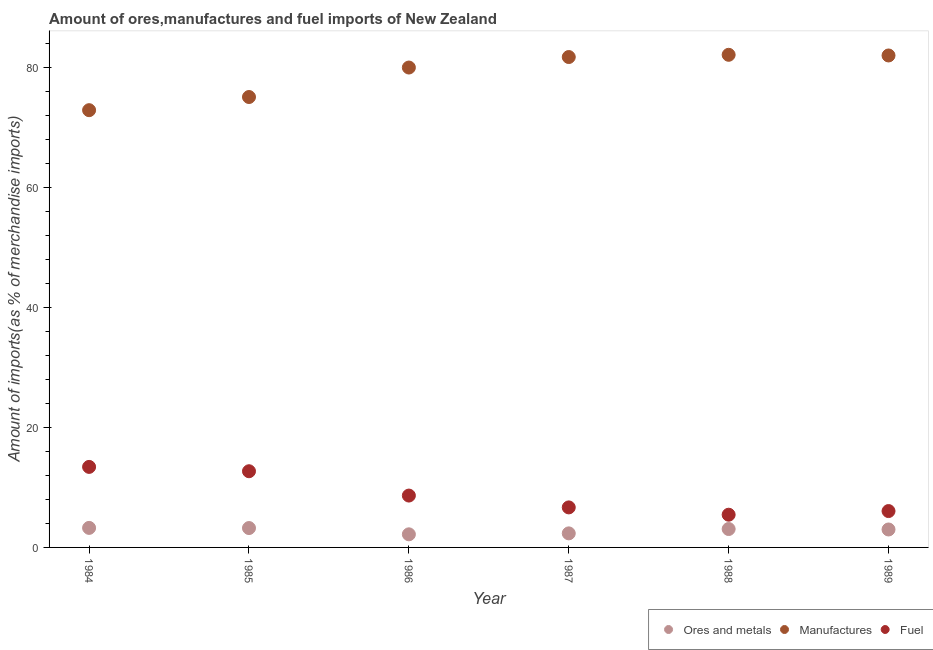Is the number of dotlines equal to the number of legend labels?
Offer a terse response. Yes. What is the percentage of ores and metals imports in 1987?
Ensure brevity in your answer.  2.34. Across all years, what is the maximum percentage of ores and metals imports?
Offer a terse response. 3.26. Across all years, what is the minimum percentage of manufactures imports?
Offer a terse response. 72.89. What is the total percentage of manufactures imports in the graph?
Offer a very short reply. 473.87. What is the difference between the percentage of manufactures imports in 1985 and that in 1986?
Offer a very short reply. -4.91. What is the difference between the percentage of fuel imports in 1989 and the percentage of ores and metals imports in 1987?
Provide a short and direct response. 3.72. What is the average percentage of manufactures imports per year?
Ensure brevity in your answer.  78.98. In the year 1985, what is the difference between the percentage of fuel imports and percentage of manufactures imports?
Provide a succinct answer. -62.39. What is the ratio of the percentage of fuel imports in 1985 to that in 1989?
Give a very brief answer. 2.1. Is the difference between the percentage of fuel imports in 1984 and 1989 greater than the difference between the percentage of manufactures imports in 1984 and 1989?
Your response must be concise. Yes. What is the difference between the highest and the second highest percentage of ores and metals imports?
Your answer should be compact. 0.03. What is the difference between the highest and the lowest percentage of fuel imports?
Make the answer very short. 7.97. In how many years, is the percentage of fuel imports greater than the average percentage of fuel imports taken over all years?
Your response must be concise. 2. Is the sum of the percentage of ores and metals imports in 1988 and 1989 greater than the maximum percentage of manufactures imports across all years?
Make the answer very short. No. Does the percentage of ores and metals imports monotonically increase over the years?
Give a very brief answer. No. Is the percentage of manufactures imports strictly greater than the percentage of ores and metals imports over the years?
Your answer should be very brief. Yes. How many dotlines are there?
Give a very brief answer. 3. Are the values on the major ticks of Y-axis written in scientific E-notation?
Your response must be concise. No. Does the graph contain any zero values?
Provide a succinct answer. No. Where does the legend appear in the graph?
Offer a very short reply. Bottom right. How many legend labels are there?
Your response must be concise. 3. What is the title of the graph?
Your answer should be compact. Amount of ores,manufactures and fuel imports of New Zealand. Does "Solid fuel" appear as one of the legend labels in the graph?
Your response must be concise. No. What is the label or title of the Y-axis?
Keep it short and to the point. Amount of imports(as % of merchandise imports). What is the Amount of imports(as % of merchandise imports) in Ores and metals in 1984?
Give a very brief answer. 3.26. What is the Amount of imports(as % of merchandise imports) of Manufactures in 1984?
Your response must be concise. 72.89. What is the Amount of imports(as % of merchandise imports) in Fuel in 1984?
Your answer should be compact. 13.42. What is the Amount of imports(as % of merchandise imports) in Ores and metals in 1985?
Your response must be concise. 3.23. What is the Amount of imports(as % of merchandise imports) of Manufactures in 1985?
Your response must be concise. 75.09. What is the Amount of imports(as % of merchandise imports) in Fuel in 1985?
Your answer should be very brief. 12.7. What is the Amount of imports(as % of merchandise imports) of Ores and metals in 1986?
Ensure brevity in your answer.  2.18. What is the Amount of imports(as % of merchandise imports) of Manufactures in 1986?
Make the answer very short. 80. What is the Amount of imports(as % of merchandise imports) of Fuel in 1986?
Keep it short and to the point. 8.64. What is the Amount of imports(as % of merchandise imports) in Ores and metals in 1987?
Provide a short and direct response. 2.34. What is the Amount of imports(as % of merchandise imports) in Manufactures in 1987?
Ensure brevity in your answer.  81.75. What is the Amount of imports(as % of merchandise imports) of Fuel in 1987?
Your answer should be very brief. 6.67. What is the Amount of imports(as % of merchandise imports) in Ores and metals in 1988?
Ensure brevity in your answer.  3.07. What is the Amount of imports(as % of merchandise imports) of Manufactures in 1988?
Provide a succinct answer. 82.12. What is the Amount of imports(as % of merchandise imports) in Fuel in 1988?
Your answer should be very brief. 5.45. What is the Amount of imports(as % of merchandise imports) of Ores and metals in 1989?
Your answer should be very brief. 2.99. What is the Amount of imports(as % of merchandise imports) in Manufactures in 1989?
Keep it short and to the point. 82.01. What is the Amount of imports(as % of merchandise imports) of Fuel in 1989?
Your response must be concise. 6.06. Across all years, what is the maximum Amount of imports(as % of merchandise imports) of Ores and metals?
Provide a short and direct response. 3.26. Across all years, what is the maximum Amount of imports(as % of merchandise imports) in Manufactures?
Make the answer very short. 82.12. Across all years, what is the maximum Amount of imports(as % of merchandise imports) of Fuel?
Your response must be concise. 13.42. Across all years, what is the minimum Amount of imports(as % of merchandise imports) of Ores and metals?
Your answer should be compact. 2.18. Across all years, what is the minimum Amount of imports(as % of merchandise imports) in Manufactures?
Make the answer very short. 72.89. Across all years, what is the minimum Amount of imports(as % of merchandise imports) in Fuel?
Ensure brevity in your answer.  5.45. What is the total Amount of imports(as % of merchandise imports) in Ores and metals in the graph?
Make the answer very short. 17.08. What is the total Amount of imports(as % of merchandise imports) of Manufactures in the graph?
Ensure brevity in your answer.  473.87. What is the total Amount of imports(as % of merchandise imports) of Fuel in the graph?
Offer a terse response. 52.96. What is the difference between the Amount of imports(as % of merchandise imports) in Ores and metals in 1984 and that in 1985?
Your response must be concise. 0.03. What is the difference between the Amount of imports(as % of merchandise imports) in Manufactures in 1984 and that in 1985?
Your answer should be compact. -2.19. What is the difference between the Amount of imports(as % of merchandise imports) of Fuel in 1984 and that in 1985?
Offer a very short reply. 0.72. What is the difference between the Amount of imports(as % of merchandise imports) of Ores and metals in 1984 and that in 1986?
Your answer should be compact. 1.07. What is the difference between the Amount of imports(as % of merchandise imports) in Manufactures in 1984 and that in 1986?
Your answer should be very brief. -7.11. What is the difference between the Amount of imports(as % of merchandise imports) of Fuel in 1984 and that in 1986?
Give a very brief answer. 4.78. What is the difference between the Amount of imports(as % of merchandise imports) of Ores and metals in 1984 and that in 1987?
Your answer should be very brief. 0.91. What is the difference between the Amount of imports(as % of merchandise imports) in Manufactures in 1984 and that in 1987?
Ensure brevity in your answer.  -8.86. What is the difference between the Amount of imports(as % of merchandise imports) in Fuel in 1984 and that in 1987?
Keep it short and to the point. 6.75. What is the difference between the Amount of imports(as % of merchandise imports) of Ores and metals in 1984 and that in 1988?
Your answer should be compact. 0.19. What is the difference between the Amount of imports(as % of merchandise imports) of Manufactures in 1984 and that in 1988?
Your answer should be compact. -9.23. What is the difference between the Amount of imports(as % of merchandise imports) in Fuel in 1984 and that in 1988?
Ensure brevity in your answer.  7.97. What is the difference between the Amount of imports(as % of merchandise imports) of Ores and metals in 1984 and that in 1989?
Keep it short and to the point. 0.26. What is the difference between the Amount of imports(as % of merchandise imports) in Manufactures in 1984 and that in 1989?
Make the answer very short. -9.12. What is the difference between the Amount of imports(as % of merchandise imports) of Fuel in 1984 and that in 1989?
Your answer should be compact. 7.36. What is the difference between the Amount of imports(as % of merchandise imports) in Ores and metals in 1985 and that in 1986?
Your response must be concise. 1.05. What is the difference between the Amount of imports(as % of merchandise imports) in Manufactures in 1985 and that in 1986?
Your response must be concise. -4.91. What is the difference between the Amount of imports(as % of merchandise imports) of Fuel in 1985 and that in 1986?
Offer a terse response. 4.06. What is the difference between the Amount of imports(as % of merchandise imports) in Ores and metals in 1985 and that in 1987?
Ensure brevity in your answer.  0.89. What is the difference between the Amount of imports(as % of merchandise imports) in Manufactures in 1985 and that in 1987?
Provide a succinct answer. -6.66. What is the difference between the Amount of imports(as % of merchandise imports) of Fuel in 1985 and that in 1987?
Offer a very short reply. 6.03. What is the difference between the Amount of imports(as % of merchandise imports) in Ores and metals in 1985 and that in 1988?
Provide a succinct answer. 0.16. What is the difference between the Amount of imports(as % of merchandise imports) in Manufactures in 1985 and that in 1988?
Provide a short and direct response. -7.04. What is the difference between the Amount of imports(as % of merchandise imports) of Fuel in 1985 and that in 1988?
Keep it short and to the point. 7.25. What is the difference between the Amount of imports(as % of merchandise imports) of Ores and metals in 1985 and that in 1989?
Your answer should be compact. 0.24. What is the difference between the Amount of imports(as % of merchandise imports) in Manufactures in 1985 and that in 1989?
Your answer should be very brief. -6.92. What is the difference between the Amount of imports(as % of merchandise imports) in Fuel in 1985 and that in 1989?
Your answer should be compact. 6.64. What is the difference between the Amount of imports(as % of merchandise imports) of Ores and metals in 1986 and that in 1987?
Ensure brevity in your answer.  -0.16. What is the difference between the Amount of imports(as % of merchandise imports) in Manufactures in 1986 and that in 1987?
Provide a succinct answer. -1.75. What is the difference between the Amount of imports(as % of merchandise imports) of Fuel in 1986 and that in 1987?
Ensure brevity in your answer.  1.97. What is the difference between the Amount of imports(as % of merchandise imports) of Ores and metals in 1986 and that in 1988?
Keep it short and to the point. -0.88. What is the difference between the Amount of imports(as % of merchandise imports) in Manufactures in 1986 and that in 1988?
Give a very brief answer. -2.12. What is the difference between the Amount of imports(as % of merchandise imports) in Fuel in 1986 and that in 1988?
Your answer should be compact. 3.19. What is the difference between the Amount of imports(as % of merchandise imports) in Ores and metals in 1986 and that in 1989?
Your answer should be compact. -0.81. What is the difference between the Amount of imports(as % of merchandise imports) in Manufactures in 1986 and that in 1989?
Your response must be concise. -2.01. What is the difference between the Amount of imports(as % of merchandise imports) of Fuel in 1986 and that in 1989?
Your answer should be compact. 2.58. What is the difference between the Amount of imports(as % of merchandise imports) in Ores and metals in 1987 and that in 1988?
Your response must be concise. -0.73. What is the difference between the Amount of imports(as % of merchandise imports) in Manufactures in 1987 and that in 1988?
Your response must be concise. -0.37. What is the difference between the Amount of imports(as % of merchandise imports) of Fuel in 1987 and that in 1988?
Your answer should be very brief. 1.22. What is the difference between the Amount of imports(as % of merchandise imports) of Ores and metals in 1987 and that in 1989?
Your answer should be compact. -0.65. What is the difference between the Amount of imports(as % of merchandise imports) of Manufactures in 1987 and that in 1989?
Provide a succinct answer. -0.26. What is the difference between the Amount of imports(as % of merchandise imports) of Fuel in 1987 and that in 1989?
Your response must be concise. 0.61. What is the difference between the Amount of imports(as % of merchandise imports) of Ores and metals in 1988 and that in 1989?
Offer a very short reply. 0.08. What is the difference between the Amount of imports(as % of merchandise imports) of Manufactures in 1988 and that in 1989?
Your answer should be compact. 0.11. What is the difference between the Amount of imports(as % of merchandise imports) of Fuel in 1988 and that in 1989?
Provide a succinct answer. -0.61. What is the difference between the Amount of imports(as % of merchandise imports) of Ores and metals in 1984 and the Amount of imports(as % of merchandise imports) of Manufactures in 1985?
Give a very brief answer. -71.83. What is the difference between the Amount of imports(as % of merchandise imports) of Ores and metals in 1984 and the Amount of imports(as % of merchandise imports) of Fuel in 1985?
Your response must be concise. -9.45. What is the difference between the Amount of imports(as % of merchandise imports) of Manufactures in 1984 and the Amount of imports(as % of merchandise imports) of Fuel in 1985?
Ensure brevity in your answer.  60.19. What is the difference between the Amount of imports(as % of merchandise imports) in Ores and metals in 1984 and the Amount of imports(as % of merchandise imports) in Manufactures in 1986?
Provide a succinct answer. -76.75. What is the difference between the Amount of imports(as % of merchandise imports) in Ores and metals in 1984 and the Amount of imports(as % of merchandise imports) in Fuel in 1986?
Provide a succinct answer. -5.39. What is the difference between the Amount of imports(as % of merchandise imports) of Manufactures in 1984 and the Amount of imports(as % of merchandise imports) of Fuel in 1986?
Give a very brief answer. 64.25. What is the difference between the Amount of imports(as % of merchandise imports) in Ores and metals in 1984 and the Amount of imports(as % of merchandise imports) in Manufactures in 1987?
Offer a very short reply. -78.5. What is the difference between the Amount of imports(as % of merchandise imports) in Ores and metals in 1984 and the Amount of imports(as % of merchandise imports) in Fuel in 1987?
Keep it short and to the point. -3.42. What is the difference between the Amount of imports(as % of merchandise imports) in Manufactures in 1984 and the Amount of imports(as % of merchandise imports) in Fuel in 1987?
Your answer should be very brief. 66.22. What is the difference between the Amount of imports(as % of merchandise imports) in Ores and metals in 1984 and the Amount of imports(as % of merchandise imports) in Manufactures in 1988?
Offer a terse response. -78.87. What is the difference between the Amount of imports(as % of merchandise imports) in Ores and metals in 1984 and the Amount of imports(as % of merchandise imports) in Fuel in 1988?
Your response must be concise. -2.2. What is the difference between the Amount of imports(as % of merchandise imports) of Manufactures in 1984 and the Amount of imports(as % of merchandise imports) of Fuel in 1988?
Your answer should be very brief. 67.44. What is the difference between the Amount of imports(as % of merchandise imports) of Ores and metals in 1984 and the Amount of imports(as % of merchandise imports) of Manufactures in 1989?
Your answer should be compact. -78.76. What is the difference between the Amount of imports(as % of merchandise imports) of Ores and metals in 1984 and the Amount of imports(as % of merchandise imports) of Fuel in 1989?
Provide a short and direct response. -2.81. What is the difference between the Amount of imports(as % of merchandise imports) of Manufactures in 1984 and the Amount of imports(as % of merchandise imports) of Fuel in 1989?
Provide a succinct answer. 66.83. What is the difference between the Amount of imports(as % of merchandise imports) in Ores and metals in 1985 and the Amount of imports(as % of merchandise imports) in Manufactures in 1986?
Give a very brief answer. -76.77. What is the difference between the Amount of imports(as % of merchandise imports) in Ores and metals in 1985 and the Amount of imports(as % of merchandise imports) in Fuel in 1986?
Give a very brief answer. -5.41. What is the difference between the Amount of imports(as % of merchandise imports) of Manufactures in 1985 and the Amount of imports(as % of merchandise imports) of Fuel in 1986?
Ensure brevity in your answer.  66.44. What is the difference between the Amount of imports(as % of merchandise imports) in Ores and metals in 1985 and the Amount of imports(as % of merchandise imports) in Manufactures in 1987?
Provide a short and direct response. -78.52. What is the difference between the Amount of imports(as % of merchandise imports) in Ores and metals in 1985 and the Amount of imports(as % of merchandise imports) in Fuel in 1987?
Provide a succinct answer. -3.44. What is the difference between the Amount of imports(as % of merchandise imports) in Manufactures in 1985 and the Amount of imports(as % of merchandise imports) in Fuel in 1987?
Offer a terse response. 68.42. What is the difference between the Amount of imports(as % of merchandise imports) in Ores and metals in 1985 and the Amount of imports(as % of merchandise imports) in Manufactures in 1988?
Offer a terse response. -78.89. What is the difference between the Amount of imports(as % of merchandise imports) in Ores and metals in 1985 and the Amount of imports(as % of merchandise imports) in Fuel in 1988?
Ensure brevity in your answer.  -2.22. What is the difference between the Amount of imports(as % of merchandise imports) of Manufactures in 1985 and the Amount of imports(as % of merchandise imports) of Fuel in 1988?
Your answer should be very brief. 69.63. What is the difference between the Amount of imports(as % of merchandise imports) of Ores and metals in 1985 and the Amount of imports(as % of merchandise imports) of Manufactures in 1989?
Keep it short and to the point. -78.78. What is the difference between the Amount of imports(as % of merchandise imports) of Ores and metals in 1985 and the Amount of imports(as % of merchandise imports) of Fuel in 1989?
Offer a very short reply. -2.83. What is the difference between the Amount of imports(as % of merchandise imports) of Manufactures in 1985 and the Amount of imports(as % of merchandise imports) of Fuel in 1989?
Offer a terse response. 69.03. What is the difference between the Amount of imports(as % of merchandise imports) in Ores and metals in 1986 and the Amount of imports(as % of merchandise imports) in Manufactures in 1987?
Keep it short and to the point. -79.57. What is the difference between the Amount of imports(as % of merchandise imports) of Ores and metals in 1986 and the Amount of imports(as % of merchandise imports) of Fuel in 1987?
Your answer should be compact. -4.49. What is the difference between the Amount of imports(as % of merchandise imports) in Manufactures in 1986 and the Amount of imports(as % of merchandise imports) in Fuel in 1987?
Keep it short and to the point. 73.33. What is the difference between the Amount of imports(as % of merchandise imports) of Ores and metals in 1986 and the Amount of imports(as % of merchandise imports) of Manufactures in 1988?
Your response must be concise. -79.94. What is the difference between the Amount of imports(as % of merchandise imports) in Ores and metals in 1986 and the Amount of imports(as % of merchandise imports) in Fuel in 1988?
Make the answer very short. -3.27. What is the difference between the Amount of imports(as % of merchandise imports) in Manufactures in 1986 and the Amount of imports(as % of merchandise imports) in Fuel in 1988?
Your answer should be compact. 74.55. What is the difference between the Amount of imports(as % of merchandise imports) in Ores and metals in 1986 and the Amount of imports(as % of merchandise imports) in Manufactures in 1989?
Your response must be concise. -79.83. What is the difference between the Amount of imports(as % of merchandise imports) of Ores and metals in 1986 and the Amount of imports(as % of merchandise imports) of Fuel in 1989?
Provide a succinct answer. -3.88. What is the difference between the Amount of imports(as % of merchandise imports) of Manufactures in 1986 and the Amount of imports(as % of merchandise imports) of Fuel in 1989?
Your response must be concise. 73.94. What is the difference between the Amount of imports(as % of merchandise imports) in Ores and metals in 1987 and the Amount of imports(as % of merchandise imports) in Manufactures in 1988?
Offer a terse response. -79.78. What is the difference between the Amount of imports(as % of merchandise imports) in Ores and metals in 1987 and the Amount of imports(as % of merchandise imports) in Fuel in 1988?
Provide a succinct answer. -3.11. What is the difference between the Amount of imports(as % of merchandise imports) of Manufactures in 1987 and the Amount of imports(as % of merchandise imports) of Fuel in 1988?
Make the answer very short. 76.3. What is the difference between the Amount of imports(as % of merchandise imports) in Ores and metals in 1987 and the Amount of imports(as % of merchandise imports) in Manufactures in 1989?
Keep it short and to the point. -79.67. What is the difference between the Amount of imports(as % of merchandise imports) of Ores and metals in 1987 and the Amount of imports(as % of merchandise imports) of Fuel in 1989?
Provide a short and direct response. -3.72. What is the difference between the Amount of imports(as % of merchandise imports) of Manufactures in 1987 and the Amount of imports(as % of merchandise imports) of Fuel in 1989?
Give a very brief answer. 75.69. What is the difference between the Amount of imports(as % of merchandise imports) of Ores and metals in 1988 and the Amount of imports(as % of merchandise imports) of Manufactures in 1989?
Make the answer very short. -78.94. What is the difference between the Amount of imports(as % of merchandise imports) in Ores and metals in 1988 and the Amount of imports(as % of merchandise imports) in Fuel in 1989?
Keep it short and to the point. -2.99. What is the difference between the Amount of imports(as % of merchandise imports) of Manufactures in 1988 and the Amount of imports(as % of merchandise imports) of Fuel in 1989?
Your answer should be compact. 76.06. What is the average Amount of imports(as % of merchandise imports) in Ores and metals per year?
Your response must be concise. 2.85. What is the average Amount of imports(as % of merchandise imports) of Manufactures per year?
Offer a very short reply. 78.98. What is the average Amount of imports(as % of merchandise imports) in Fuel per year?
Offer a terse response. 8.83. In the year 1984, what is the difference between the Amount of imports(as % of merchandise imports) in Ores and metals and Amount of imports(as % of merchandise imports) in Manufactures?
Keep it short and to the point. -69.64. In the year 1984, what is the difference between the Amount of imports(as % of merchandise imports) of Ores and metals and Amount of imports(as % of merchandise imports) of Fuel?
Your answer should be compact. -10.17. In the year 1984, what is the difference between the Amount of imports(as % of merchandise imports) of Manufactures and Amount of imports(as % of merchandise imports) of Fuel?
Keep it short and to the point. 59.47. In the year 1985, what is the difference between the Amount of imports(as % of merchandise imports) in Ores and metals and Amount of imports(as % of merchandise imports) in Manufactures?
Give a very brief answer. -71.86. In the year 1985, what is the difference between the Amount of imports(as % of merchandise imports) of Ores and metals and Amount of imports(as % of merchandise imports) of Fuel?
Ensure brevity in your answer.  -9.47. In the year 1985, what is the difference between the Amount of imports(as % of merchandise imports) of Manufactures and Amount of imports(as % of merchandise imports) of Fuel?
Offer a terse response. 62.39. In the year 1986, what is the difference between the Amount of imports(as % of merchandise imports) in Ores and metals and Amount of imports(as % of merchandise imports) in Manufactures?
Your response must be concise. -77.82. In the year 1986, what is the difference between the Amount of imports(as % of merchandise imports) in Ores and metals and Amount of imports(as % of merchandise imports) in Fuel?
Offer a very short reply. -6.46. In the year 1986, what is the difference between the Amount of imports(as % of merchandise imports) in Manufactures and Amount of imports(as % of merchandise imports) in Fuel?
Offer a terse response. 71.36. In the year 1987, what is the difference between the Amount of imports(as % of merchandise imports) of Ores and metals and Amount of imports(as % of merchandise imports) of Manufactures?
Give a very brief answer. -79.41. In the year 1987, what is the difference between the Amount of imports(as % of merchandise imports) of Ores and metals and Amount of imports(as % of merchandise imports) of Fuel?
Offer a terse response. -4.33. In the year 1987, what is the difference between the Amount of imports(as % of merchandise imports) in Manufactures and Amount of imports(as % of merchandise imports) in Fuel?
Give a very brief answer. 75.08. In the year 1988, what is the difference between the Amount of imports(as % of merchandise imports) of Ores and metals and Amount of imports(as % of merchandise imports) of Manufactures?
Offer a terse response. -79.05. In the year 1988, what is the difference between the Amount of imports(as % of merchandise imports) in Ores and metals and Amount of imports(as % of merchandise imports) in Fuel?
Your response must be concise. -2.39. In the year 1988, what is the difference between the Amount of imports(as % of merchandise imports) in Manufactures and Amount of imports(as % of merchandise imports) in Fuel?
Provide a short and direct response. 76.67. In the year 1989, what is the difference between the Amount of imports(as % of merchandise imports) of Ores and metals and Amount of imports(as % of merchandise imports) of Manufactures?
Your answer should be very brief. -79.02. In the year 1989, what is the difference between the Amount of imports(as % of merchandise imports) of Ores and metals and Amount of imports(as % of merchandise imports) of Fuel?
Offer a terse response. -3.07. In the year 1989, what is the difference between the Amount of imports(as % of merchandise imports) of Manufactures and Amount of imports(as % of merchandise imports) of Fuel?
Your response must be concise. 75.95. What is the ratio of the Amount of imports(as % of merchandise imports) in Manufactures in 1984 to that in 1985?
Your answer should be compact. 0.97. What is the ratio of the Amount of imports(as % of merchandise imports) of Fuel in 1984 to that in 1985?
Provide a short and direct response. 1.06. What is the ratio of the Amount of imports(as % of merchandise imports) in Ores and metals in 1984 to that in 1986?
Make the answer very short. 1.49. What is the ratio of the Amount of imports(as % of merchandise imports) in Manufactures in 1984 to that in 1986?
Keep it short and to the point. 0.91. What is the ratio of the Amount of imports(as % of merchandise imports) of Fuel in 1984 to that in 1986?
Your answer should be very brief. 1.55. What is the ratio of the Amount of imports(as % of merchandise imports) of Ores and metals in 1984 to that in 1987?
Your response must be concise. 1.39. What is the ratio of the Amount of imports(as % of merchandise imports) of Manufactures in 1984 to that in 1987?
Provide a succinct answer. 0.89. What is the ratio of the Amount of imports(as % of merchandise imports) of Fuel in 1984 to that in 1987?
Give a very brief answer. 2.01. What is the ratio of the Amount of imports(as % of merchandise imports) in Ores and metals in 1984 to that in 1988?
Your answer should be very brief. 1.06. What is the ratio of the Amount of imports(as % of merchandise imports) in Manufactures in 1984 to that in 1988?
Keep it short and to the point. 0.89. What is the ratio of the Amount of imports(as % of merchandise imports) of Fuel in 1984 to that in 1988?
Provide a succinct answer. 2.46. What is the ratio of the Amount of imports(as % of merchandise imports) in Ores and metals in 1984 to that in 1989?
Give a very brief answer. 1.09. What is the ratio of the Amount of imports(as % of merchandise imports) in Manufactures in 1984 to that in 1989?
Offer a very short reply. 0.89. What is the ratio of the Amount of imports(as % of merchandise imports) of Fuel in 1984 to that in 1989?
Your response must be concise. 2.21. What is the ratio of the Amount of imports(as % of merchandise imports) in Ores and metals in 1985 to that in 1986?
Offer a very short reply. 1.48. What is the ratio of the Amount of imports(as % of merchandise imports) of Manufactures in 1985 to that in 1986?
Make the answer very short. 0.94. What is the ratio of the Amount of imports(as % of merchandise imports) in Fuel in 1985 to that in 1986?
Keep it short and to the point. 1.47. What is the ratio of the Amount of imports(as % of merchandise imports) of Ores and metals in 1985 to that in 1987?
Keep it short and to the point. 1.38. What is the ratio of the Amount of imports(as % of merchandise imports) of Manufactures in 1985 to that in 1987?
Your response must be concise. 0.92. What is the ratio of the Amount of imports(as % of merchandise imports) of Fuel in 1985 to that in 1987?
Offer a terse response. 1.9. What is the ratio of the Amount of imports(as % of merchandise imports) in Ores and metals in 1985 to that in 1988?
Offer a terse response. 1.05. What is the ratio of the Amount of imports(as % of merchandise imports) of Manufactures in 1985 to that in 1988?
Ensure brevity in your answer.  0.91. What is the ratio of the Amount of imports(as % of merchandise imports) of Fuel in 1985 to that in 1988?
Your response must be concise. 2.33. What is the ratio of the Amount of imports(as % of merchandise imports) in Ores and metals in 1985 to that in 1989?
Your answer should be compact. 1.08. What is the ratio of the Amount of imports(as % of merchandise imports) of Manufactures in 1985 to that in 1989?
Ensure brevity in your answer.  0.92. What is the ratio of the Amount of imports(as % of merchandise imports) of Fuel in 1985 to that in 1989?
Keep it short and to the point. 2.1. What is the ratio of the Amount of imports(as % of merchandise imports) of Ores and metals in 1986 to that in 1987?
Your answer should be compact. 0.93. What is the ratio of the Amount of imports(as % of merchandise imports) in Manufactures in 1986 to that in 1987?
Your answer should be very brief. 0.98. What is the ratio of the Amount of imports(as % of merchandise imports) of Fuel in 1986 to that in 1987?
Your response must be concise. 1.3. What is the ratio of the Amount of imports(as % of merchandise imports) in Ores and metals in 1986 to that in 1988?
Make the answer very short. 0.71. What is the ratio of the Amount of imports(as % of merchandise imports) of Manufactures in 1986 to that in 1988?
Offer a very short reply. 0.97. What is the ratio of the Amount of imports(as % of merchandise imports) of Fuel in 1986 to that in 1988?
Your response must be concise. 1.58. What is the ratio of the Amount of imports(as % of merchandise imports) of Ores and metals in 1986 to that in 1989?
Your answer should be very brief. 0.73. What is the ratio of the Amount of imports(as % of merchandise imports) in Manufactures in 1986 to that in 1989?
Provide a short and direct response. 0.98. What is the ratio of the Amount of imports(as % of merchandise imports) of Fuel in 1986 to that in 1989?
Your response must be concise. 1.43. What is the ratio of the Amount of imports(as % of merchandise imports) in Ores and metals in 1987 to that in 1988?
Give a very brief answer. 0.76. What is the ratio of the Amount of imports(as % of merchandise imports) in Fuel in 1987 to that in 1988?
Your answer should be very brief. 1.22. What is the ratio of the Amount of imports(as % of merchandise imports) of Ores and metals in 1987 to that in 1989?
Offer a very short reply. 0.78. What is the ratio of the Amount of imports(as % of merchandise imports) in Fuel in 1987 to that in 1989?
Offer a terse response. 1.1. What is the ratio of the Amount of imports(as % of merchandise imports) in Ores and metals in 1988 to that in 1989?
Your response must be concise. 1.03. What is the ratio of the Amount of imports(as % of merchandise imports) of Fuel in 1988 to that in 1989?
Give a very brief answer. 0.9. What is the difference between the highest and the second highest Amount of imports(as % of merchandise imports) of Ores and metals?
Make the answer very short. 0.03. What is the difference between the highest and the second highest Amount of imports(as % of merchandise imports) of Manufactures?
Offer a very short reply. 0.11. What is the difference between the highest and the second highest Amount of imports(as % of merchandise imports) of Fuel?
Provide a succinct answer. 0.72. What is the difference between the highest and the lowest Amount of imports(as % of merchandise imports) of Ores and metals?
Ensure brevity in your answer.  1.07. What is the difference between the highest and the lowest Amount of imports(as % of merchandise imports) of Manufactures?
Provide a succinct answer. 9.23. What is the difference between the highest and the lowest Amount of imports(as % of merchandise imports) in Fuel?
Offer a very short reply. 7.97. 